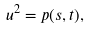<formula> <loc_0><loc_0><loc_500><loc_500>u ^ { 2 } = p ( s , t ) ,</formula> 